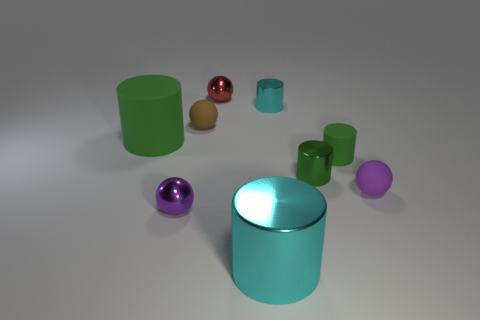How many objects appear to be spheres? There are two objects that are spherical in shape, one in a shade of purple and the other in a red tone. 